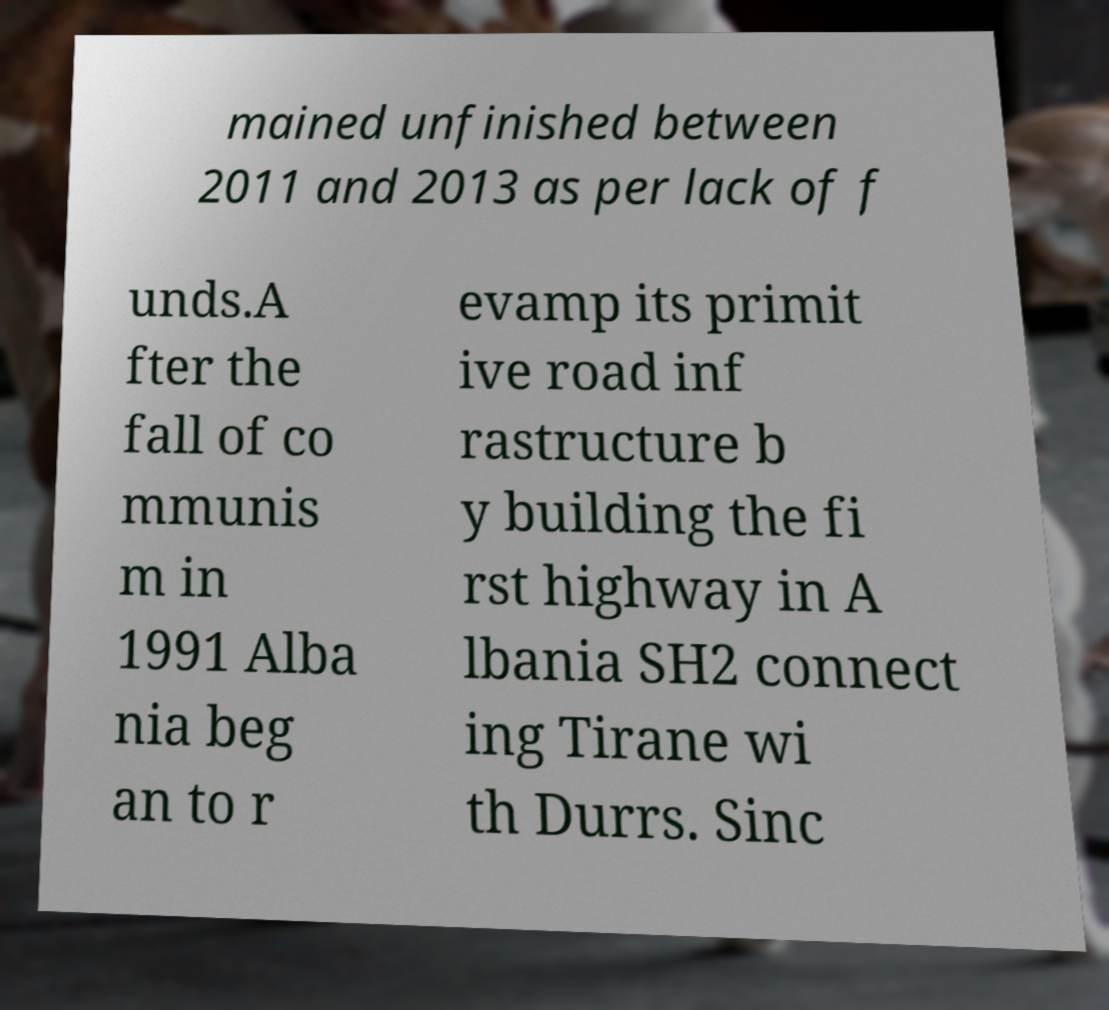What messages or text are displayed in this image? I need them in a readable, typed format. mained unfinished between 2011 and 2013 as per lack of f unds.A fter the fall of co mmunis m in 1991 Alba nia beg an to r evamp its primit ive road inf rastructure b y building the fi rst highway in A lbania SH2 connect ing Tirane wi th Durrs. Sinc 